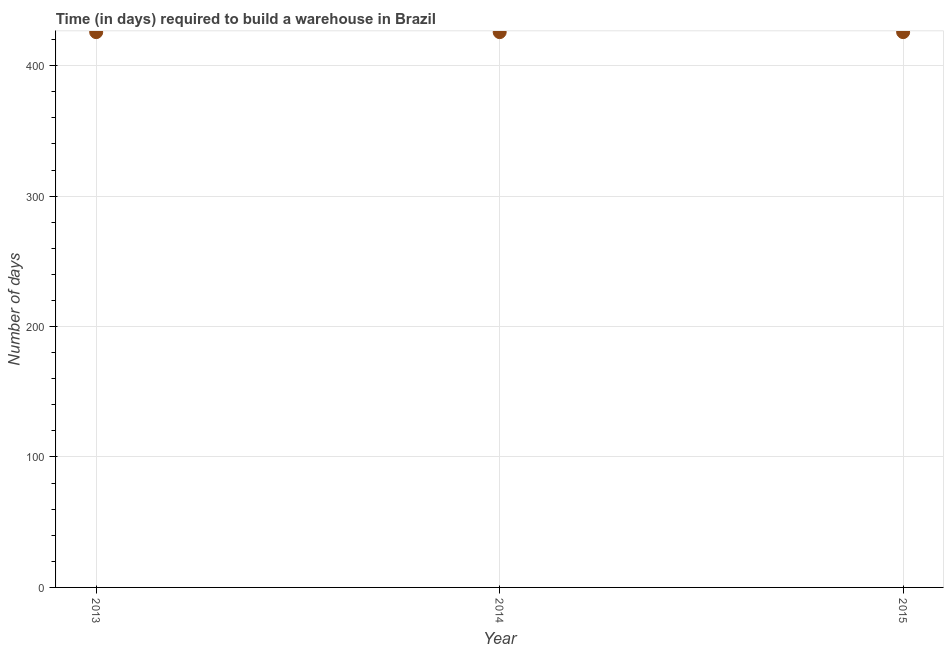What is the time required to build a warehouse in 2014?
Provide a short and direct response. 425.7. Across all years, what is the maximum time required to build a warehouse?
Your response must be concise. 425.7. Across all years, what is the minimum time required to build a warehouse?
Your answer should be compact. 425.7. What is the sum of the time required to build a warehouse?
Keep it short and to the point. 1277.1. What is the average time required to build a warehouse per year?
Make the answer very short. 425.7. What is the median time required to build a warehouse?
Give a very brief answer. 425.7. In how many years, is the time required to build a warehouse greater than 120 days?
Your answer should be compact. 3. Is the time required to build a warehouse in 2014 less than that in 2015?
Offer a terse response. No. Is the sum of the time required to build a warehouse in 2013 and 2015 greater than the maximum time required to build a warehouse across all years?
Offer a terse response. Yes. How many years are there in the graph?
Provide a short and direct response. 3. What is the difference between two consecutive major ticks on the Y-axis?
Offer a terse response. 100. Are the values on the major ticks of Y-axis written in scientific E-notation?
Offer a very short reply. No. Does the graph contain any zero values?
Your response must be concise. No. Does the graph contain grids?
Your answer should be very brief. Yes. What is the title of the graph?
Offer a terse response. Time (in days) required to build a warehouse in Brazil. What is the label or title of the X-axis?
Ensure brevity in your answer.  Year. What is the label or title of the Y-axis?
Offer a very short reply. Number of days. What is the Number of days in 2013?
Make the answer very short. 425.7. What is the Number of days in 2014?
Provide a succinct answer. 425.7. What is the Number of days in 2015?
Your answer should be compact. 425.7. What is the difference between the Number of days in 2013 and 2014?
Your response must be concise. 0. What is the difference between the Number of days in 2014 and 2015?
Offer a very short reply. 0. What is the ratio of the Number of days in 2013 to that in 2015?
Give a very brief answer. 1. What is the ratio of the Number of days in 2014 to that in 2015?
Your response must be concise. 1. 